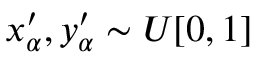Convert formula to latex. <formula><loc_0><loc_0><loc_500><loc_500>x _ { \alpha } ^ { \prime } , y _ { \alpha } ^ { \prime } \sim U [ 0 , 1 ]</formula> 